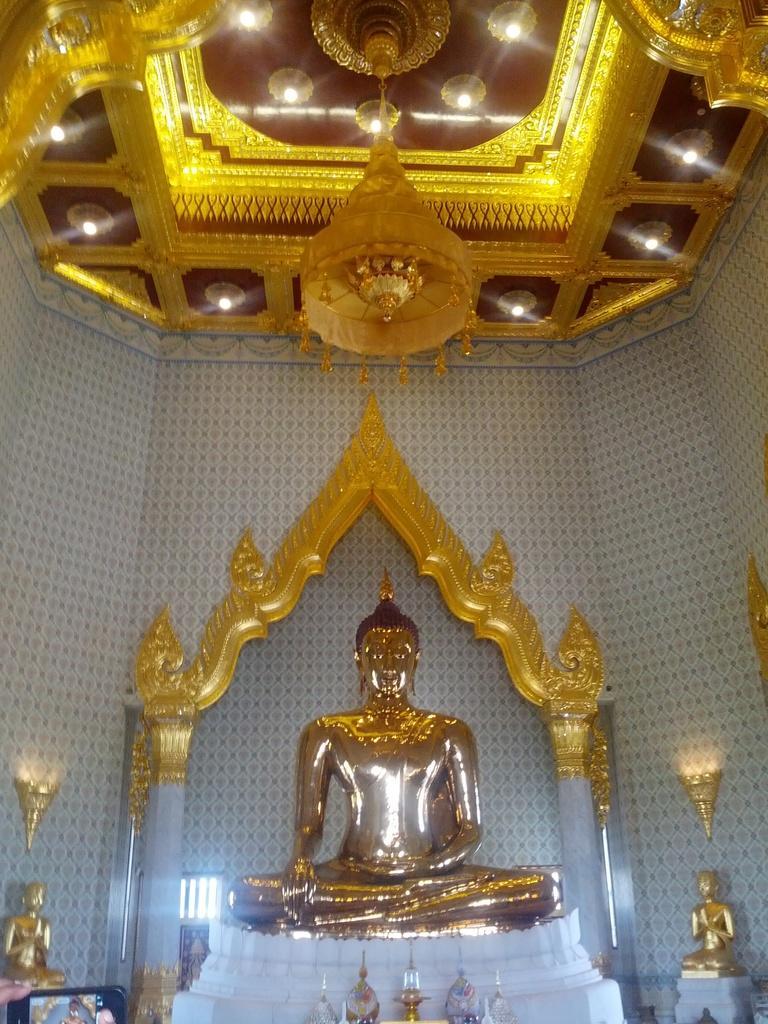Describe this image in one or two sentences. In this image we can see temple of golden Buddha. The roof of the temple is decorated with golden color thing. The walls are in white and blue color. In front of the Buddha statue, things are present. 